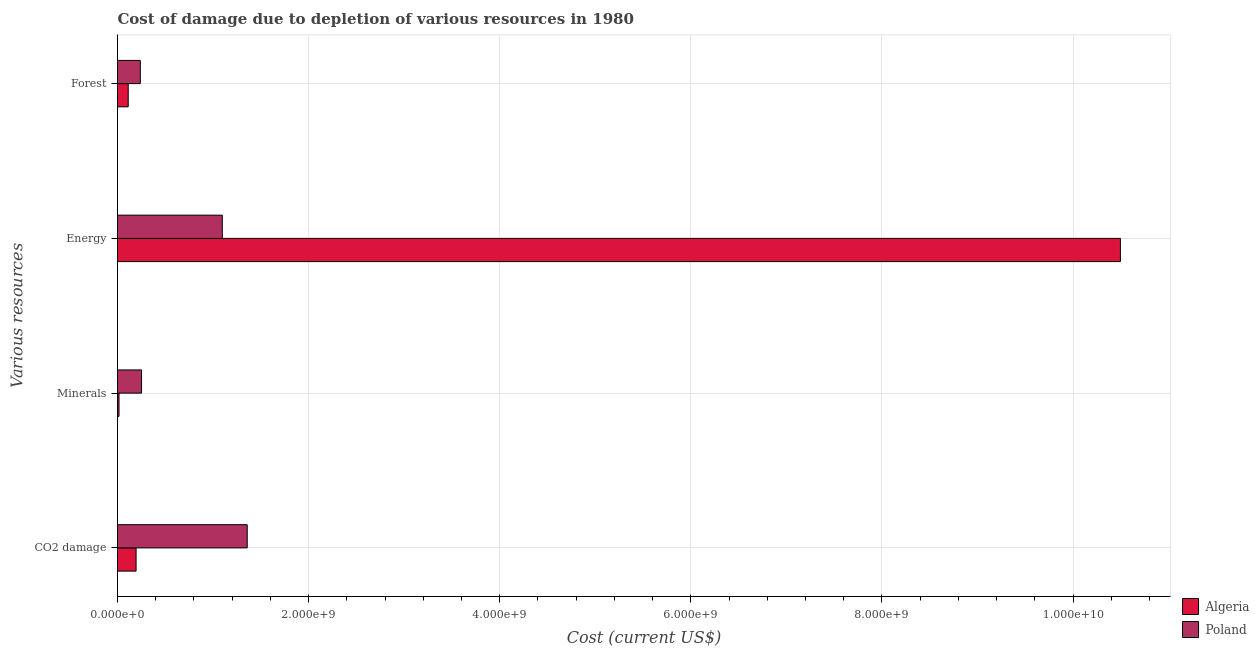How many different coloured bars are there?
Your answer should be very brief. 2. Are the number of bars per tick equal to the number of legend labels?
Provide a succinct answer. Yes. Are the number of bars on each tick of the Y-axis equal?
Give a very brief answer. Yes. How many bars are there on the 3rd tick from the top?
Provide a succinct answer. 2. How many bars are there on the 1st tick from the bottom?
Provide a succinct answer. 2. What is the label of the 2nd group of bars from the top?
Your answer should be compact. Energy. What is the cost of damage due to depletion of coal in Poland?
Provide a succinct answer. 1.36e+09. Across all countries, what is the maximum cost of damage due to depletion of forests?
Make the answer very short. 2.39e+08. Across all countries, what is the minimum cost of damage due to depletion of minerals?
Make the answer very short. 1.57e+07. In which country was the cost of damage due to depletion of minerals minimum?
Make the answer very short. Algeria. What is the total cost of damage due to depletion of coal in the graph?
Your answer should be very brief. 1.55e+09. What is the difference between the cost of damage due to depletion of energy in Poland and that in Algeria?
Your answer should be compact. -9.40e+09. What is the difference between the cost of damage due to depletion of minerals in Algeria and the cost of damage due to depletion of energy in Poland?
Make the answer very short. -1.08e+09. What is the average cost of damage due to depletion of forests per country?
Your response must be concise. 1.75e+08. What is the difference between the cost of damage due to depletion of energy and cost of damage due to depletion of minerals in Poland?
Offer a terse response. 8.45e+08. What is the ratio of the cost of damage due to depletion of energy in Poland to that in Algeria?
Your answer should be compact. 0.1. Is the cost of damage due to depletion of minerals in Algeria less than that in Poland?
Your answer should be compact. Yes. What is the difference between the highest and the second highest cost of damage due to depletion of forests?
Provide a short and direct response. 1.27e+08. What is the difference between the highest and the lowest cost of damage due to depletion of forests?
Your answer should be very brief. 1.27e+08. In how many countries, is the cost of damage due to depletion of minerals greater than the average cost of damage due to depletion of minerals taken over all countries?
Offer a terse response. 1. Is it the case that in every country, the sum of the cost of damage due to depletion of energy and cost of damage due to depletion of forests is greater than the sum of cost of damage due to depletion of coal and cost of damage due to depletion of minerals?
Offer a very short reply. No. What does the 2nd bar from the top in Forest represents?
Your answer should be compact. Algeria. What does the 1st bar from the bottom in CO2 damage represents?
Ensure brevity in your answer.  Algeria. Is it the case that in every country, the sum of the cost of damage due to depletion of coal and cost of damage due to depletion of minerals is greater than the cost of damage due to depletion of energy?
Ensure brevity in your answer.  No. How many bars are there?
Your response must be concise. 8. How many countries are there in the graph?
Ensure brevity in your answer.  2. Are the values on the major ticks of X-axis written in scientific E-notation?
Your answer should be very brief. Yes. How many legend labels are there?
Your answer should be compact. 2. What is the title of the graph?
Provide a short and direct response. Cost of damage due to depletion of various resources in 1980 . What is the label or title of the X-axis?
Your answer should be very brief. Cost (current US$). What is the label or title of the Y-axis?
Your answer should be very brief. Various resources. What is the Cost (current US$) of Algeria in CO2 damage?
Your answer should be compact. 1.94e+08. What is the Cost (current US$) of Poland in CO2 damage?
Your response must be concise. 1.36e+09. What is the Cost (current US$) in Algeria in Minerals?
Offer a very short reply. 1.57e+07. What is the Cost (current US$) in Poland in Minerals?
Ensure brevity in your answer.  2.51e+08. What is the Cost (current US$) of Algeria in Energy?
Offer a terse response. 1.05e+1. What is the Cost (current US$) in Poland in Energy?
Give a very brief answer. 1.10e+09. What is the Cost (current US$) in Algeria in Forest?
Your response must be concise. 1.12e+08. What is the Cost (current US$) in Poland in Forest?
Your answer should be compact. 2.39e+08. Across all Various resources, what is the maximum Cost (current US$) of Algeria?
Your response must be concise. 1.05e+1. Across all Various resources, what is the maximum Cost (current US$) in Poland?
Offer a very short reply. 1.36e+09. Across all Various resources, what is the minimum Cost (current US$) of Algeria?
Keep it short and to the point. 1.57e+07. Across all Various resources, what is the minimum Cost (current US$) in Poland?
Ensure brevity in your answer.  2.39e+08. What is the total Cost (current US$) of Algeria in the graph?
Your response must be concise. 1.08e+1. What is the total Cost (current US$) of Poland in the graph?
Your response must be concise. 2.94e+09. What is the difference between the Cost (current US$) of Algeria in CO2 damage and that in Minerals?
Make the answer very short. 1.79e+08. What is the difference between the Cost (current US$) in Poland in CO2 damage and that in Minerals?
Provide a succinct answer. 1.11e+09. What is the difference between the Cost (current US$) of Algeria in CO2 damage and that in Energy?
Ensure brevity in your answer.  -1.03e+1. What is the difference between the Cost (current US$) in Poland in CO2 damage and that in Energy?
Your answer should be compact. 2.61e+08. What is the difference between the Cost (current US$) of Algeria in CO2 damage and that in Forest?
Provide a succinct answer. 8.23e+07. What is the difference between the Cost (current US$) in Poland in CO2 damage and that in Forest?
Provide a succinct answer. 1.12e+09. What is the difference between the Cost (current US$) of Algeria in Minerals and that in Energy?
Your response must be concise. -1.05e+1. What is the difference between the Cost (current US$) in Poland in Minerals and that in Energy?
Make the answer very short. -8.45e+08. What is the difference between the Cost (current US$) in Algeria in Minerals and that in Forest?
Your answer should be compact. -9.63e+07. What is the difference between the Cost (current US$) in Poland in Minerals and that in Forest?
Keep it short and to the point. 1.29e+07. What is the difference between the Cost (current US$) of Algeria in Energy and that in Forest?
Offer a terse response. 1.04e+1. What is the difference between the Cost (current US$) of Poland in Energy and that in Forest?
Your answer should be very brief. 8.58e+08. What is the difference between the Cost (current US$) in Algeria in CO2 damage and the Cost (current US$) in Poland in Minerals?
Ensure brevity in your answer.  -5.71e+07. What is the difference between the Cost (current US$) of Algeria in CO2 damage and the Cost (current US$) of Poland in Energy?
Your answer should be very brief. -9.02e+08. What is the difference between the Cost (current US$) of Algeria in CO2 damage and the Cost (current US$) of Poland in Forest?
Your response must be concise. -4.42e+07. What is the difference between the Cost (current US$) in Algeria in Minerals and the Cost (current US$) in Poland in Energy?
Your answer should be compact. -1.08e+09. What is the difference between the Cost (current US$) in Algeria in Minerals and the Cost (current US$) in Poland in Forest?
Make the answer very short. -2.23e+08. What is the difference between the Cost (current US$) in Algeria in Energy and the Cost (current US$) in Poland in Forest?
Offer a terse response. 1.03e+1. What is the average Cost (current US$) of Algeria per Various resources?
Offer a terse response. 2.70e+09. What is the average Cost (current US$) in Poland per Various resources?
Provide a short and direct response. 7.36e+08. What is the difference between the Cost (current US$) of Algeria and Cost (current US$) of Poland in CO2 damage?
Make the answer very short. -1.16e+09. What is the difference between the Cost (current US$) in Algeria and Cost (current US$) in Poland in Minerals?
Offer a terse response. -2.36e+08. What is the difference between the Cost (current US$) of Algeria and Cost (current US$) of Poland in Energy?
Keep it short and to the point. 9.40e+09. What is the difference between the Cost (current US$) of Algeria and Cost (current US$) of Poland in Forest?
Your response must be concise. -1.27e+08. What is the ratio of the Cost (current US$) of Algeria in CO2 damage to that in Minerals?
Offer a very short reply. 12.35. What is the ratio of the Cost (current US$) of Poland in CO2 damage to that in Minerals?
Your answer should be very brief. 5.4. What is the ratio of the Cost (current US$) in Algeria in CO2 damage to that in Energy?
Ensure brevity in your answer.  0.02. What is the ratio of the Cost (current US$) in Poland in CO2 damage to that in Energy?
Your answer should be compact. 1.24. What is the ratio of the Cost (current US$) in Algeria in CO2 damage to that in Forest?
Your answer should be compact. 1.73. What is the ratio of the Cost (current US$) of Poland in CO2 damage to that in Forest?
Ensure brevity in your answer.  5.69. What is the ratio of the Cost (current US$) in Algeria in Minerals to that in Energy?
Your response must be concise. 0. What is the ratio of the Cost (current US$) of Poland in Minerals to that in Energy?
Offer a terse response. 0.23. What is the ratio of the Cost (current US$) of Algeria in Minerals to that in Forest?
Keep it short and to the point. 0.14. What is the ratio of the Cost (current US$) of Poland in Minerals to that in Forest?
Make the answer very short. 1.05. What is the ratio of the Cost (current US$) in Algeria in Energy to that in Forest?
Ensure brevity in your answer.  93.67. What is the ratio of the Cost (current US$) in Poland in Energy to that in Forest?
Offer a very short reply. 4.6. What is the difference between the highest and the second highest Cost (current US$) of Algeria?
Your response must be concise. 1.03e+1. What is the difference between the highest and the second highest Cost (current US$) of Poland?
Offer a terse response. 2.61e+08. What is the difference between the highest and the lowest Cost (current US$) in Algeria?
Offer a very short reply. 1.05e+1. What is the difference between the highest and the lowest Cost (current US$) in Poland?
Give a very brief answer. 1.12e+09. 